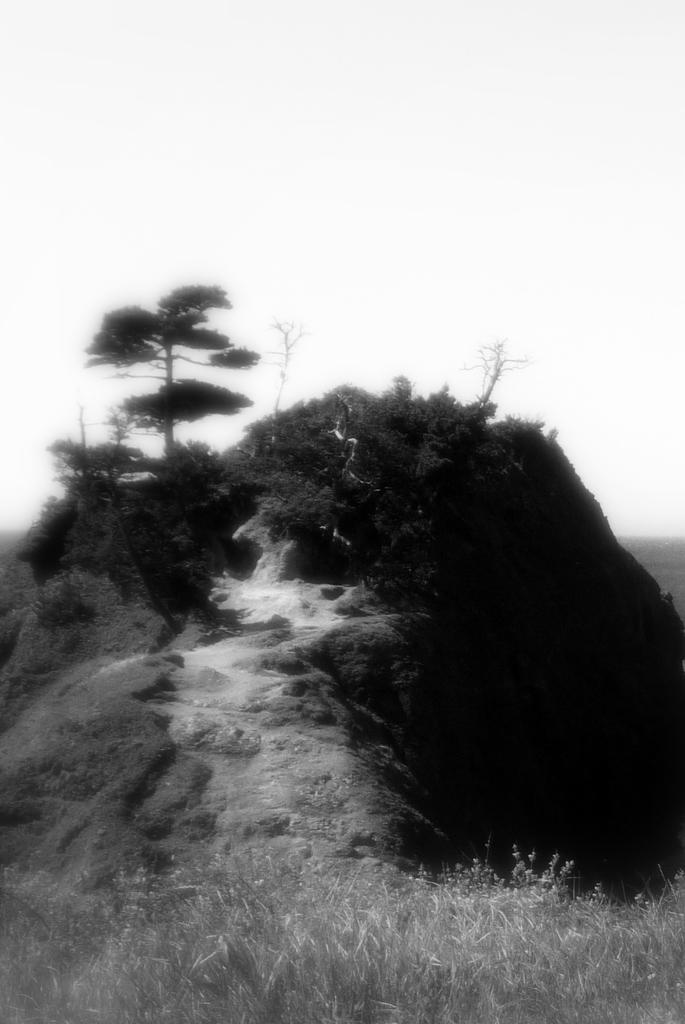What is the color scheme of the image? The image is black and white. What geographical feature can be seen in the image? There is a hill in the image. What type of vegetation is present on the hill? There are trees and plants on the hill. What type of ground cover is visible below the hill? There is grass below the hill. Can you see any feathers floating in the air in the image? No, there are no feathers visible in the image. What type of corn is growing on the hill in the image? There is no corn present in the image; it features a hill with trees, plants, and grass. 